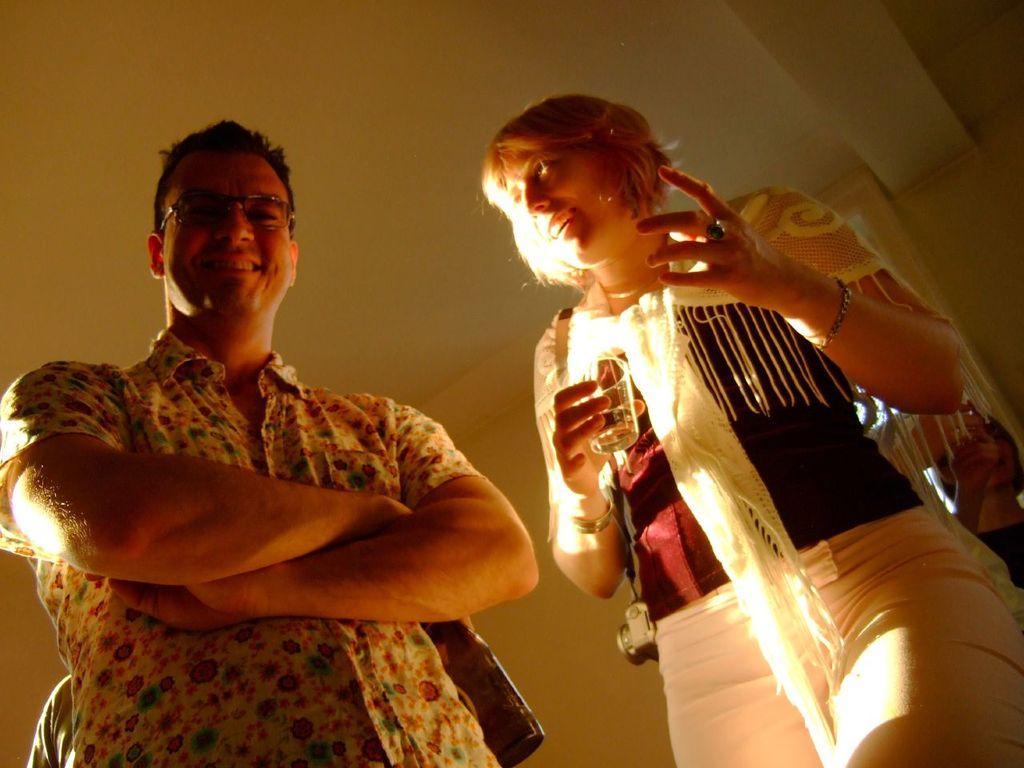Please provide a concise description of this image. In this image there are two persons standing, one is holding a glass in her hand, in the background there is wall, at the top there is a ceiling. 